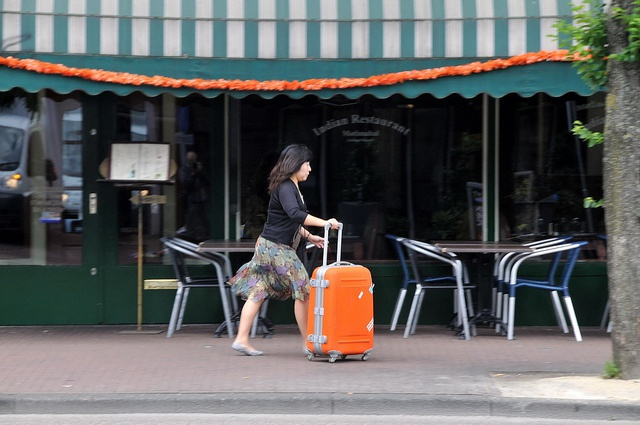Describe the objects in this image and their specific colors. I can see people in teal, black, gray, darkgray, and lightgray tones, suitcase in teal, red, salmon, lavender, and darkgray tones, car in teal, black, gray, darkgray, and darkblue tones, chair in teal, black, white, navy, and darkgray tones, and chair in teal, black, gray, and darkgray tones in this image. 